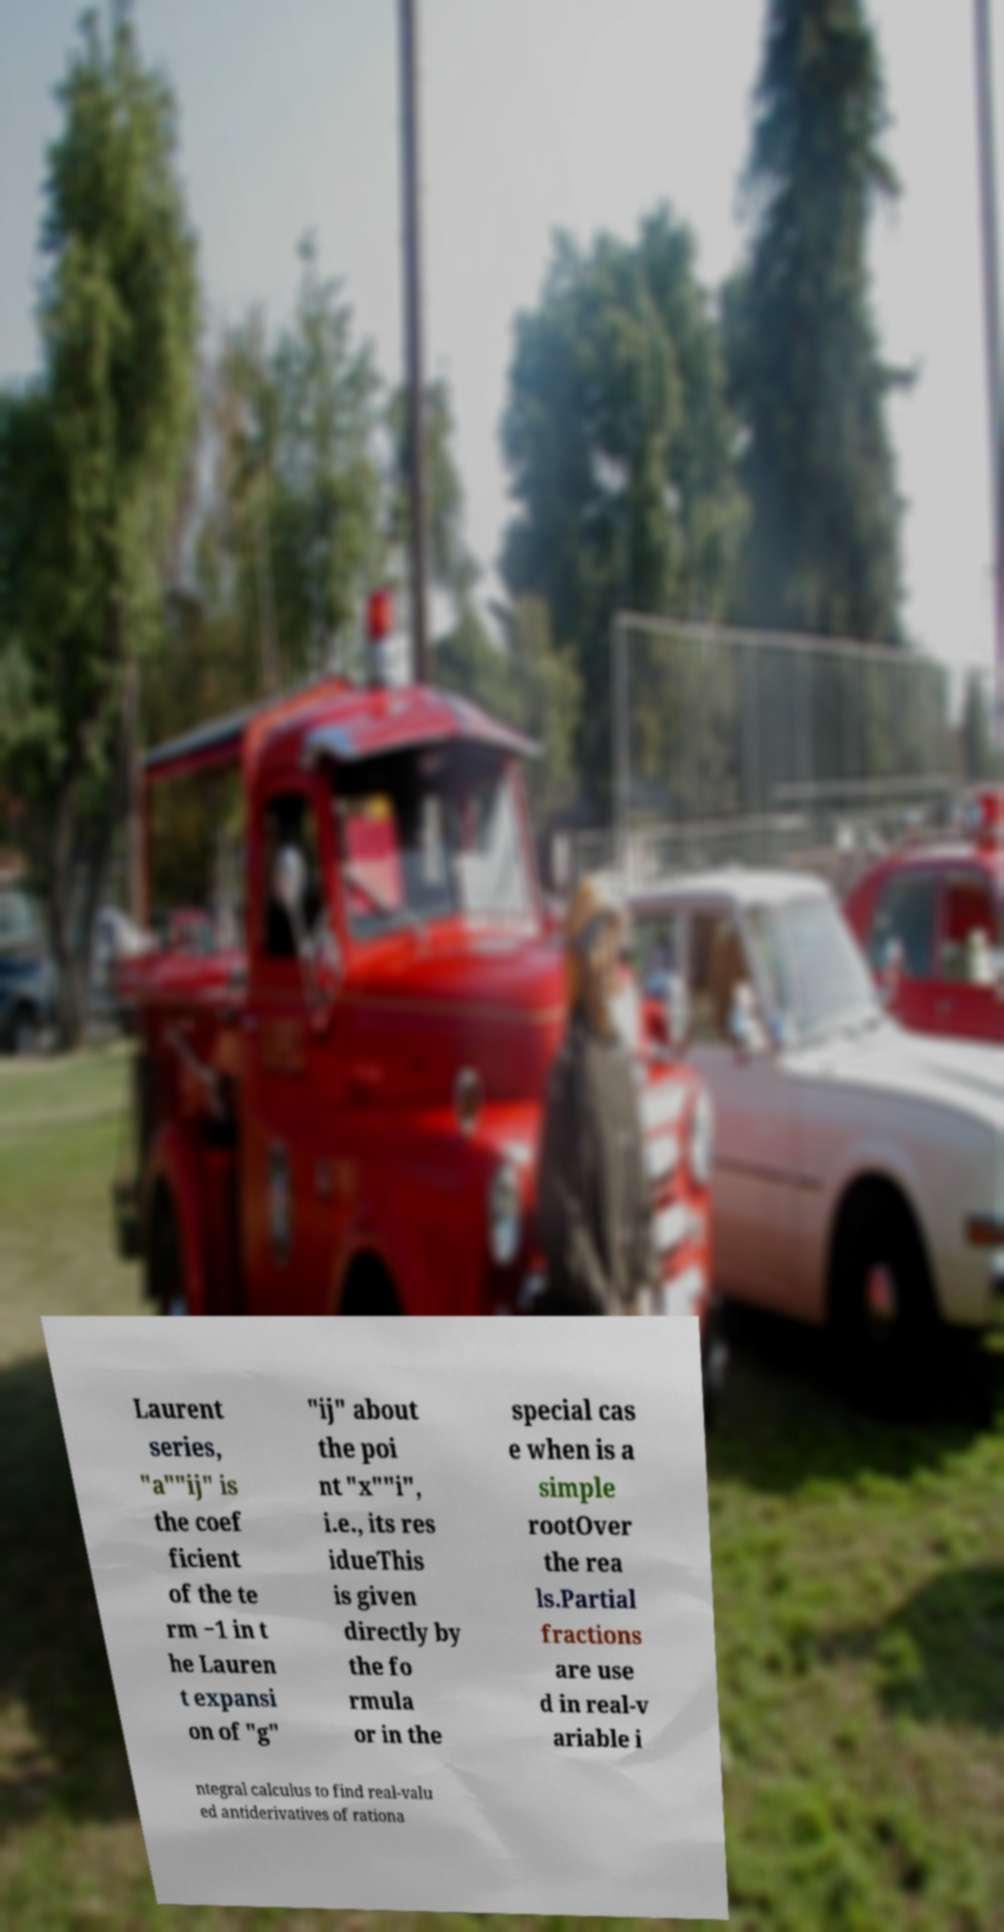Please identify and transcribe the text found in this image. Laurent series, "a""ij" is the coef ficient of the te rm −1 in t he Lauren t expansi on of "g" "ij" about the poi nt "x""i", i.e., its res idueThis is given directly by the fo rmula or in the special cas e when is a simple rootOver the rea ls.Partial fractions are use d in real-v ariable i ntegral calculus to find real-valu ed antiderivatives of rationa 